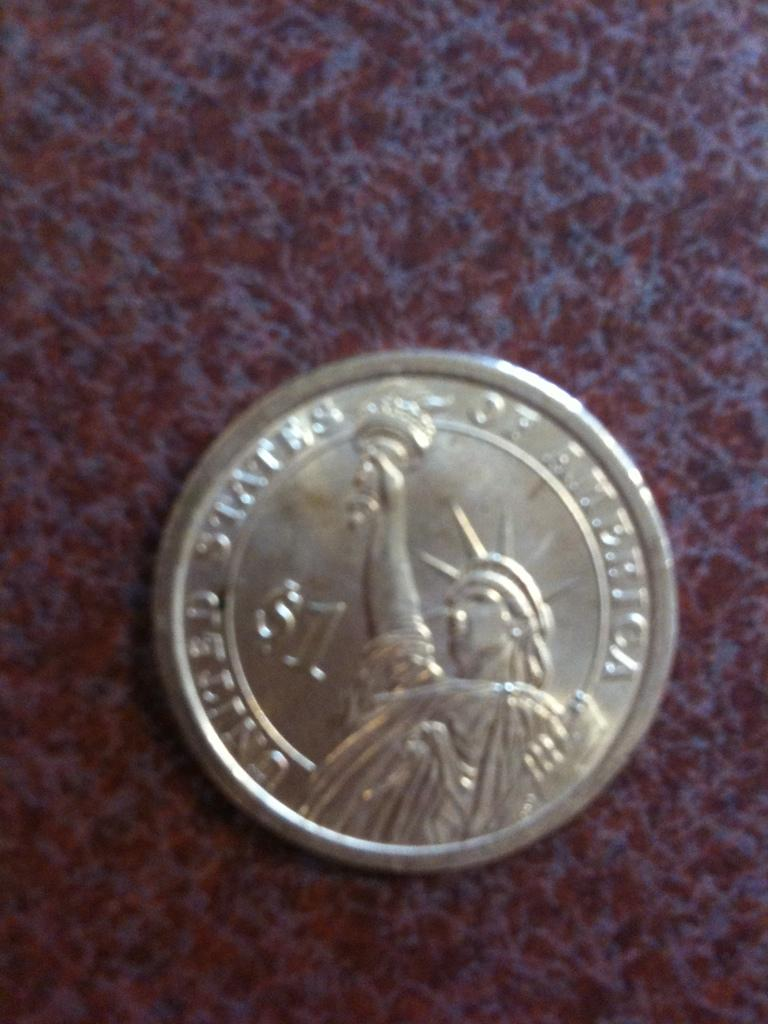<image>
Create a compact narrative representing the image presented. A silver coin that is made in the United States of America 